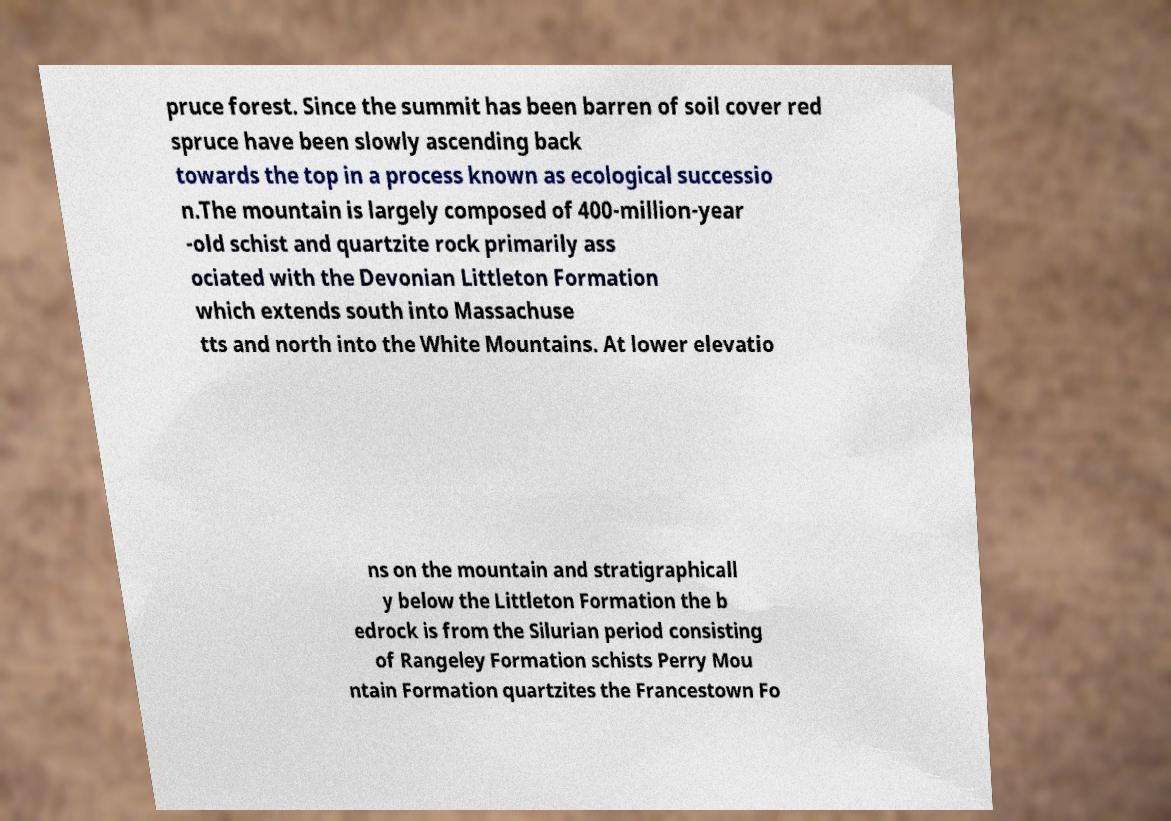Please identify and transcribe the text found in this image. pruce forest. Since the summit has been barren of soil cover red spruce have been slowly ascending back towards the top in a process known as ecological successio n.The mountain is largely composed of 400-million-year -old schist and quartzite rock primarily ass ociated with the Devonian Littleton Formation which extends south into Massachuse tts and north into the White Mountains. At lower elevatio ns on the mountain and stratigraphicall y below the Littleton Formation the b edrock is from the Silurian period consisting of Rangeley Formation schists Perry Mou ntain Formation quartzites the Francestown Fo 